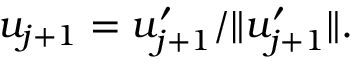Convert formula to latex. <formula><loc_0><loc_0><loc_500><loc_500>u _ { j + 1 } = u _ { j + 1 } ^ { \prime } / \| u _ { j + 1 } ^ { \prime } \| .</formula> 